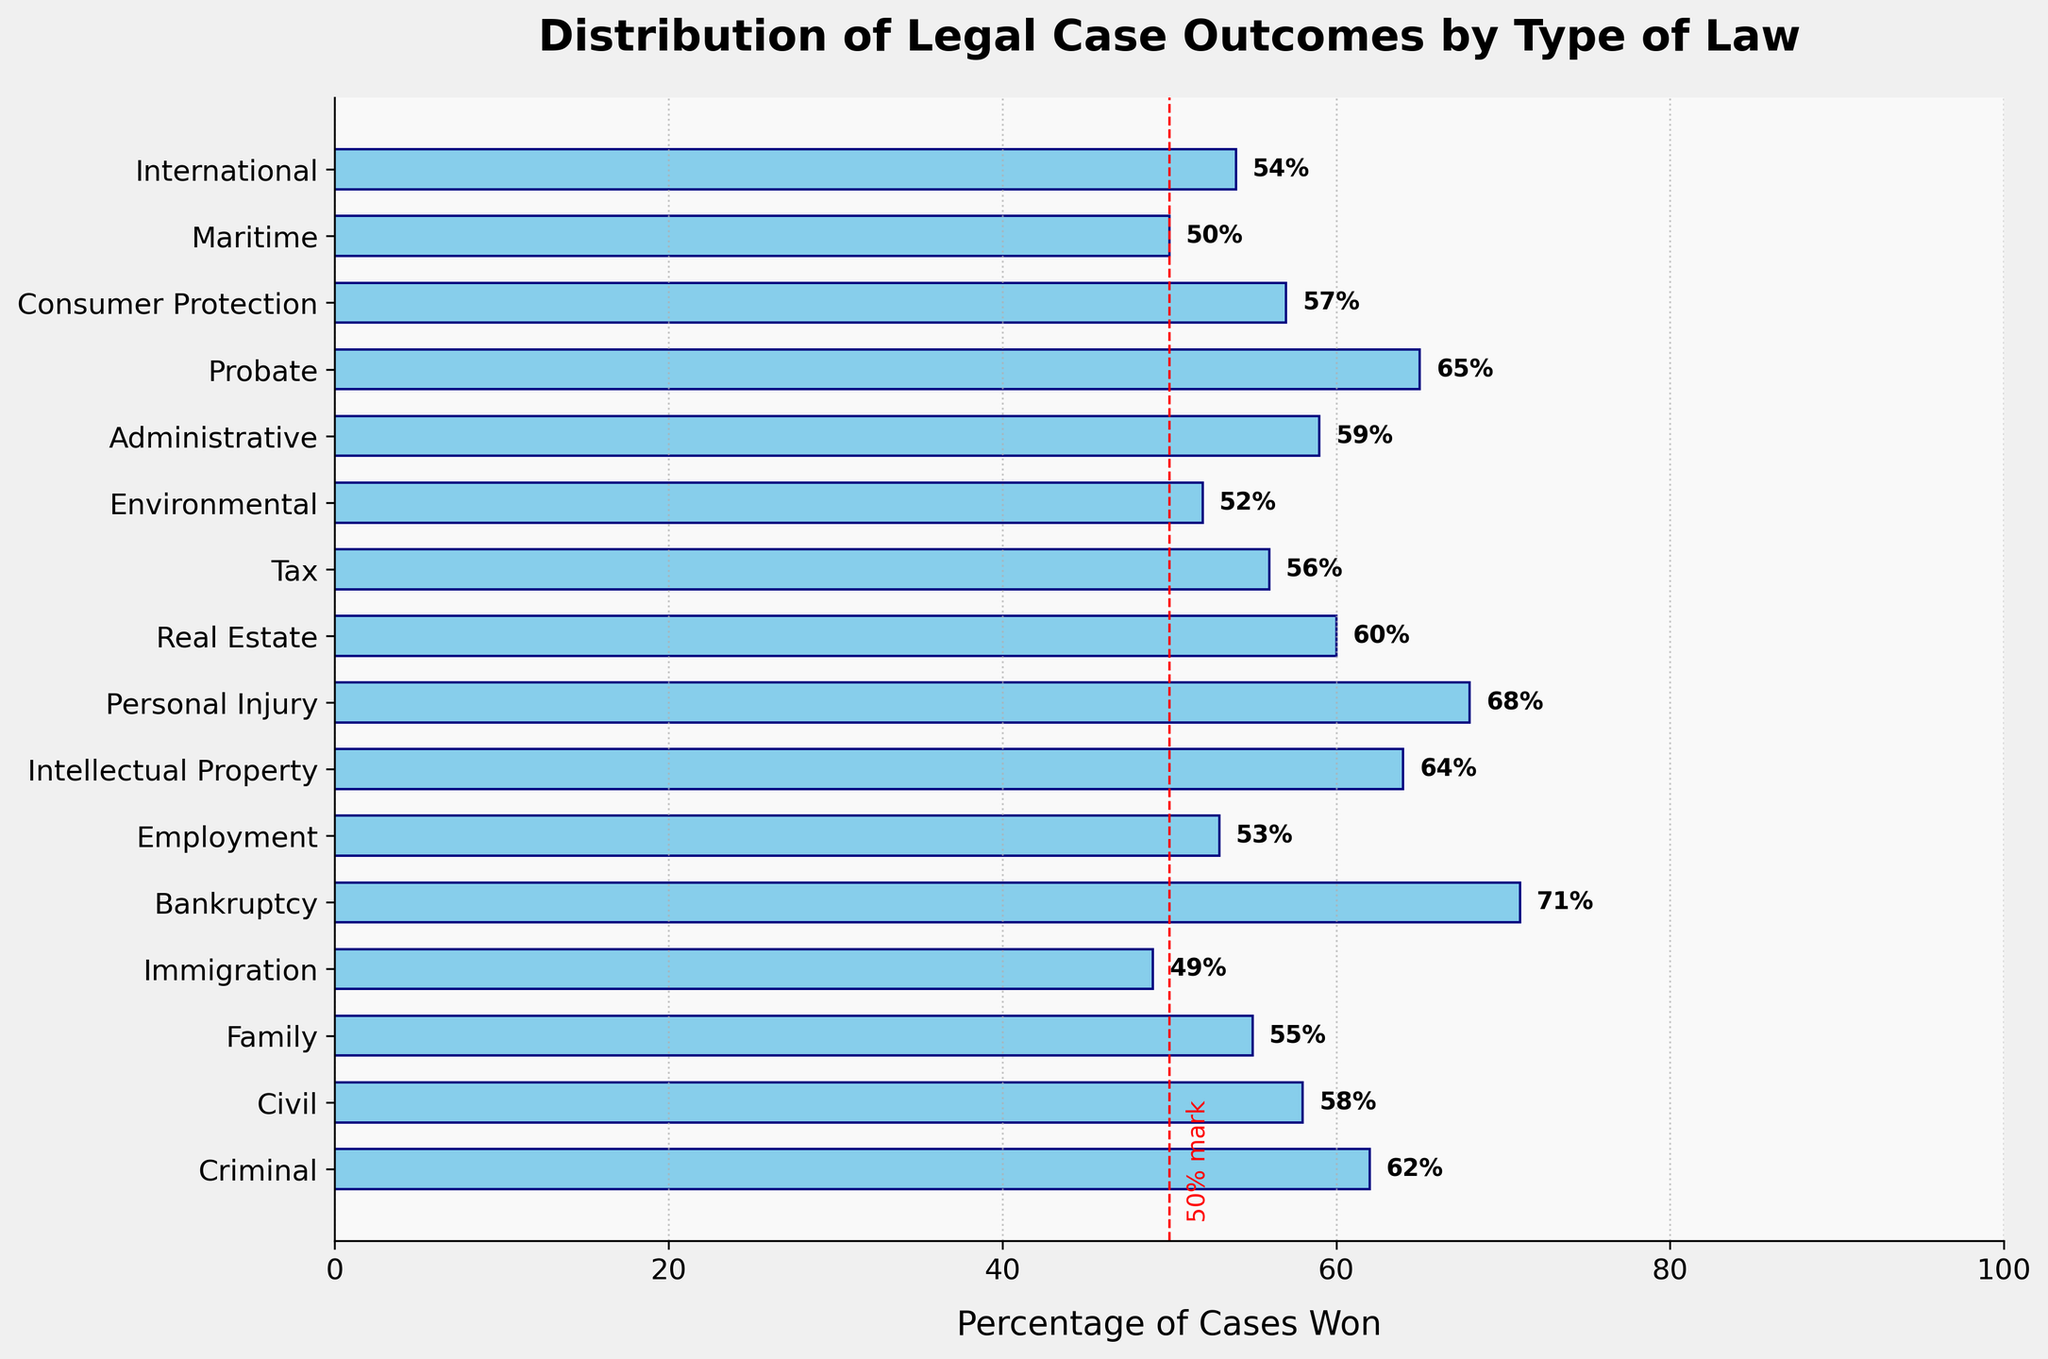What's the percentage of cases won for Criminal law? Look for the bar labeled "Criminal" and read the percentage at the end of the bar or the label on it.
Answer: 62% Which type of law has the highest percentage of cases won? Identify the bar that extends the furthest to the right. This bar represents the highest percentage of cases won. The label at the end of this bar indicates the type of law.
Answer: Bankruptcy Which type of law has the lowest percentage of cases won? Identify the bar that is the shortest and has the smallest percentage label. This bar represents the lowest percentage of cases won. The label at the end of this bar indicates the type of law.
Answer: Immigration What's the difference between the percentage of cases won in Criminal law and Civil law? Subtract the percentage of Civil law cases won from the percentage of Criminal law cases won. (62% − 58%)
Answer: 4% What's the average percentage of cases won in Family, Immigration, and Bankruptcy law? Add the percentages of Family, Immigration, and Bankruptcy cases won, then divide by the number of types included (55 + 49 + 71)/3
Answer: 58.33 Are there more types of law with a percentage of cases won above 60% or below 60%? Count the number of bars with a percentage label above 60%. Count the number of bars with a percentage label below 60%. Compare the counts.
Answer: Above 60% Which type of law has a percentage of cases won closest to the 50% mark? Look for the bar with a percentage nearest to 50%. The vertical red dashed line at 50% can serve as a reference.
Answer: Maritime How many types of law have a percentage of cases won greater than 65%? Count the bars with a percentage label greater than 65%.
Answer: 2 What's the total percentage of cases won for Criminal, Civil, Family, and Tax law combined? Add the percentages of Criminal, Civil, Family, and Tax law cases won. (62 + 58 + 55 + 56)
Answer: 231% Are there more types of law with a percentage of cases won between 50% to 60%, or between 60% to 70%? Count the number of bars with a percentage label between 50% and 60%. Count the number of bars with a percentage label between 60% and 70%. Compare the counts.
Answer: 50% to 60% 